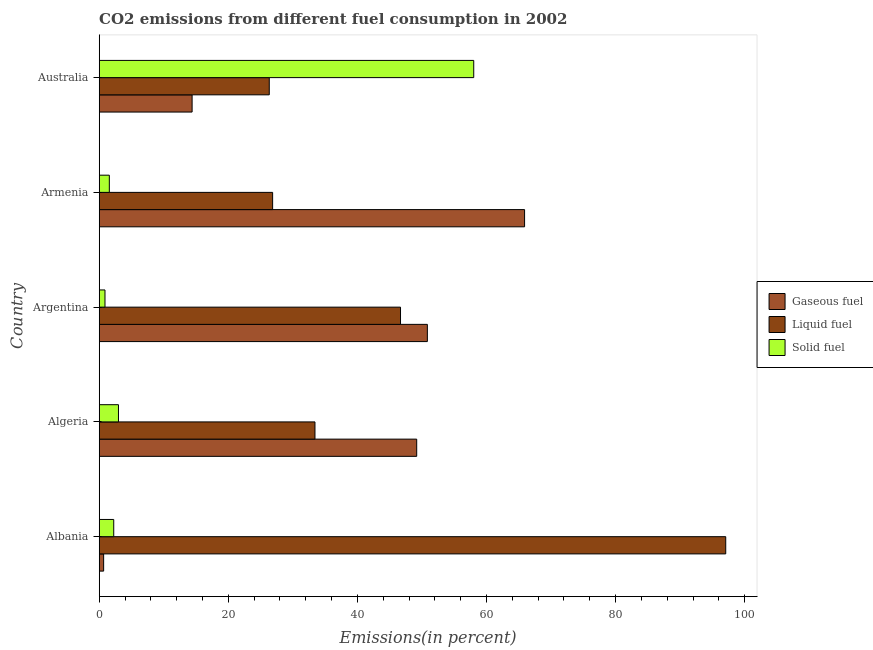How many different coloured bars are there?
Your answer should be compact. 3. Are the number of bars per tick equal to the number of legend labels?
Keep it short and to the point. Yes. How many bars are there on the 5th tick from the top?
Keep it short and to the point. 3. How many bars are there on the 3rd tick from the bottom?
Ensure brevity in your answer.  3. In how many cases, is the number of bars for a given country not equal to the number of legend labels?
Offer a very short reply. 0. What is the percentage of solid fuel emission in Argentina?
Give a very brief answer. 0.89. Across all countries, what is the maximum percentage of liquid fuel emission?
Your response must be concise. 97.07. Across all countries, what is the minimum percentage of gaseous fuel emission?
Make the answer very short. 0.68. In which country was the percentage of gaseous fuel emission maximum?
Offer a very short reply. Armenia. What is the total percentage of liquid fuel emission in the graph?
Your answer should be very brief. 230.39. What is the difference between the percentage of solid fuel emission in Armenia and that in Australia?
Offer a terse response. -56.46. What is the difference between the percentage of gaseous fuel emission in Argentina and the percentage of liquid fuel emission in Albania?
Your response must be concise. -46.23. What is the average percentage of gaseous fuel emission per country?
Offer a very short reply. 36.2. What is the difference between the percentage of gaseous fuel emission and percentage of liquid fuel emission in Albania?
Your response must be concise. -96.38. In how many countries, is the percentage of solid fuel emission greater than 8 %?
Your answer should be very brief. 1. What is the ratio of the percentage of solid fuel emission in Algeria to that in Armenia?
Your answer should be compact. 1.9. Is the percentage of liquid fuel emission in Albania less than that in Australia?
Your response must be concise. No. Is the difference between the percentage of liquid fuel emission in Albania and Australia greater than the difference between the percentage of solid fuel emission in Albania and Australia?
Your answer should be compact. Yes. What is the difference between the highest and the second highest percentage of gaseous fuel emission?
Provide a succinct answer. 15.06. What is the difference between the highest and the lowest percentage of liquid fuel emission?
Provide a succinct answer. 70.72. In how many countries, is the percentage of liquid fuel emission greater than the average percentage of liquid fuel emission taken over all countries?
Make the answer very short. 2. What does the 2nd bar from the top in Australia represents?
Make the answer very short. Liquid fuel. What does the 2nd bar from the bottom in Albania represents?
Your answer should be very brief. Liquid fuel. How many bars are there?
Your answer should be compact. 15. Are all the bars in the graph horizontal?
Offer a terse response. Yes. Are the values on the major ticks of X-axis written in scientific E-notation?
Offer a very short reply. No. Does the graph contain any zero values?
Keep it short and to the point. No. How many legend labels are there?
Offer a very short reply. 3. How are the legend labels stacked?
Your response must be concise. Vertical. What is the title of the graph?
Provide a short and direct response. CO2 emissions from different fuel consumption in 2002. What is the label or title of the X-axis?
Provide a short and direct response. Emissions(in percent). What is the Emissions(in percent) of Gaseous fuel in Albania?
Your answer should be compact. 0.68. What is the Emissions(in percent) in Liquid fuel in Albania?
Offer a very short reply. 97.07. What is the Emissions(in percent) of Solid fuel in Albania?
Your answer should be very brief. 2.25. What is the Emissions(in percent) in Gaseous fuel in Algeria?
Your answer should be very brief. 49.19. What is the Emissions(in percent) of Liquid fuel in Algeria?
Keep it short and to the point. 33.43. What is the Emissions(in percent) in Solid fuel in Algeria?
Make the answer very short. 2.98. What is the Emissions(in percent) of Gaseous fuel in Argentina?
Keep it short and to the point. 50.84. What is the Emissions(in percent) of Liquid fuel in Argentina?
Keep it short and to the point. 46.68. What is the Emissions(in percent) in Solid fuel in Argentina?
Your answer should be very brief. 0.89. What is the Emissions(in percent) of Gaseous fuel in Armenia?
Your answer should be compact. 65.9. What is the Emissions(in percent) in Liquid fuel in Armenia?
Provide a short and direct response. 26.87. What is the Emissions(in percent) of Solid fuel in Armenia?
Keep it short and to the point. 1.57. What is the Emissions(in percent) of Gaseous fuel in Australia?
Offer a very short reply. 14.39. What is the Emissions(in percent) in Liquid fuel in Australia?
Keep it short and to the point. 26.35. What is the Emissions(in percent) in Solid fuel in Australia?
Your answer should be compact. 58.03. Across all countries, what is the maximum Emissions(in percent) in Gaseous fuel?
Your answer should be compact. 65.9. Across all countries, what is the maximum Emissions(in percent) of Liquid fuel?
Provide a short and direct response. 97.07. Across all countries, what is the maximum Emissions(in percent) of Solid fuel?
Make the answer very short. 58.03. Across all countries, what is the minimum Emissions(in percent) in Gaseous fuel?
Provide a succinct answer. 0.68. Across all countries, what is the minimum Emissions(in percent) in Liquid fuel?
Provide a succinct answer. 26.35. Across all countries, what is the minimum Emissions(in percent) in Solid fuel?
Keep it short and to the point. 0.89. What is the total Emissions(in percent) in Gaseous fuel in the graph?
Offer a terse response. 181.01. What is the total Emissions(in percent) of Liquid fuel in the graph?
Provide a succinct answer. 230.39. What is the total Emissions(in percent) in Solid fuel in the graph?
Your response must be concise. 65.72. What is the difference between the Emissions(in percent) in Gaseous fuel in Albania and that in Algeria?
Provide a succinct answer. -48.5. What is the difference between the Emissions(in percent) in Liquid fuel in Albania and that in Algeria?
Give a very brief answer. 63.64. What is the difference between the Emissions(in percent) in Solid fuel in Albania and that in Algeria?
Your answer should be compact. -0.73. What is the difference between the Emissions(in percent) of Gaseous fuel in Albania and that in Argentina?
Offer a very short reply. -50.16. What is the difference between the Emissions(in percent) of Liquid fuel in Albania and that in Argentina?
Make the answer very short. 50.39. What is the difference between the Emissions(in percent) in Solid fuel in Albania and that in Argentina?
Offer a very short reply. 1.36. What is the difference between the Emissions(in percent) in Gaseous fuel in Albania and that in Armenia?
Give a very brief answer. -65.22. What is the difference between the Emissions(in percent) of Liquid fuel in Albania and that in Armenia?
Provide a succinct answer. 70.2. What is the difference between the Emissions(in percent) in Solid fuel in Albania and that in Armenia?
Offer a terse response. 0.68. What is the difference between the Emissions(in percent) of Gaseous fuel in Albania and that in Australia?
Keep it short and to the point. -13.71. What is the difference between the Emissions(in percent) of Liquid fuel in Albania and that in Australia?
Provide a succinct answer. 70.72. What is the difference between the Emissions(in percent) of Solid fuel in Albania and that in Australia?
Provide a succinct answer. -55.78. What is the difference between the Emissions(in percent) of Gaseous fuel in Algeria and that in Argentina?
Provide a succinct answer. -1.65. What is the difference between the Emissions(in percent) in Liquid fuel in Algeria and that in Argentina?
Give a very brief answer. -13.25. What is the difference between the Emissions(in percent) of Solid fuel in Algeria and that in Argentina?
Provide a short and direct response. 2.09. What is the difference between the Emissions(in percent) in Gaseous fuel in Algeria and that in Armenia?
Your response must be concise. -16.71. What is the difference between the Emissions(in percent) of Liquid fuel in Algeria and that in Armenia?
Make the answer very short. 6.56. What is the difference between the Emissions(in percent) in Solid fuel in Algeria and that in Armenia?
Ensure brevity in your answer.  1.42. What is the difference between the Emissions(in percent) in Gaseous fuel in Algeria and that in Australia?
Provide a short and direct response. 34.8. What is the difference between the Emissions(in percent) in Liquid fuel in Algeria and that in Australia?
Your answer should be compact. 7.08. What is the difference between the Emissions(in percent) in Solid fuel in Algeria and that in Australia?
Keep it short and to the point. -55.04. What is the difference between the Emissions(in percent) of Gaseous fuel in Argentina and that in Armenia?
Offer a terse response. -15.06. What is the difference between the Emissions(in percent) in Liquid fuel in Argentina and that in Armenia?
Offer a very short reply. 19.81. What is the difference between the Emissions(in percent) in Solid fuel in Argentina and that in Armenia?
Make the answer very short. -0.67. What is the difference between the Emissions(in percent) of Gaseous fuel in Argentina and that in Australia?
Offer a very short reply. 36.45. What is the difference between the Emissions(in percent) of Liquid fuel in Argentina and that in Australia?
Ensure brevity in your answer.  20.34. What is the difference between the Emissions(in percent) in Solid fuel in Argentina and that in Australia?
Your response must be concise. -57.13. What is the difference between the Emissions(in percent) in Gaseous fuel in Armenia and that in Australia?
Provide a succinct answer. 51.51. What is the difference between the Emissions(in percent) of Liquid fuel in Armenia and that in Australia?
Offer a very short reply. 0.52. What is the difference between the Emissions(in percent) of Solid fuel in Armenia and that in Australia?
Make the answer very short. -56.46. What is the difference between the Emissions(in percent) of Gaseous fuel in Albania and the Emissions(in percent) of Liquid fuel in Algeria?
Keep it short and to the point. -32.74. What is the difference between the Emissions(in percent) of Gaseous fuel in Albania and the Emissions(in percent) of Solid fuel in Algeria?
Provide a short and direct response. -2.3. What is the difference between the Emissions(in percent) in Liquid fuel in Albania and the Emissions(in percent) in Solid fuel in Algeria?
Give a very brief answer. 94.08. What is the difference between the Emissions(in percent) of Gaseous fuel in Albania and the Emissions(in percent) of Liquid fuel in Argentina?
Your answer should be very brief. -46. What is the difference between the Emissions(in percent) in Gaseous fuel in Albania and the Emissions(in percent) in Solid fuel in Argentina?
Provide a succinct answer. -0.21. What is the difference between the Emissions(in percent) in Liquid fuel in Albania and the Emissions(in percent) in Solid fuel in Argentina?
Your answer should be compact. 96.17. What is the difference between the Emissions(in percent) of Gaseous fuel in Albania and the Emissions(in percent) of Liquid fuel in Armenia?
Ensure brevity in your answer.  -26.18. What is the difference between the Emissions(in percent) of Gaseous fuel in Albania and the Emissions(in percent) of Solid fuel in Armenia?
Provide a short and direct response. -0.88. What is the difference between the Emissions(in percent) of Liquid fuel in Albania and the Emissions(in percent) of Solid fuel in Armenia?
Your answer should be very brief. 95.5. What is the difference between the Emissions(in percent) in Gaseous fuel in Albania and the Emissions(in percent) in Liquid fuel in Australia?
Offer a very short reply. -25.66. What is the difference between the Emissions(in percent) in Gaseous fuel in Albania and the Emissions(in percent) in Solid fuel in Australia?
Your answer should be compact. -57.34. What is the difference between the Emissions(in percent) of Liquid fuel in Albania and the Emissions(in percent) of Solid fuel in Australia?
Offer a very short reply. 39.04. What is the difference between the Emissions(in percent) in Gaseous fuel in Algeria and the Emissions(in percent) in Liquid fuel in Argentina?
Provide a succinct answer. 2.51. What is the difference between the Emissions(in percent) in Gaseous fuel in Algeria and the Emissions(in percent) in Solid fuel in Argentina?
Provide a succinct answer. 48.3. What is the difference between the Emissions(in percent) in Liquid fuel in Algeria and the Emissions(in percent) in Solid fuel in Argentina?
Your answer should be compact. 32.54. What is the difference between the Emissions(in percent) in Gaseous fuel in Algeria and the Emissions(in percent) in Liquid fuel in Armenia?
Keep it short and to the point. 22.32. What is the difference between the Emissions(in percent) of Gaseous fuel in Algeria and the Emissions(in percent) of Solid fuel in Armenia?
Provide a short and direct response. 47.62. What is the difference between the Emissions(in percent) in Liquid fuel in Algeria and the Emissions(in percent) in Solid fuel in Armenia?
Offer a very short reply. 31.86. What is the difference between the Emissions(in percent) in Gaseous fuel in Algeria and the Emissions(in percent) in Liquid fuel in Australia?
Ensure brevity in your answer.  22.84. What is the difference between the Emissions(in percent) in Gaseous fuel in Algeria and the Emissions(in percent) in Solid fuel in Australia?
Give a very brief answer. -8.84. What is the difference between the Emissions(in percent) of Liquid fuel in Algeria and the Emissions(in percent) of Solid fuel in Australia?
Your answer should be compact. -24.6. What is the difference between the Emissions(in percent) of Gaseous fuel in Argentina and the Emissions(in percent) of Liquid fuel in Armenia?
Offer a terse response. 23.97. What is the difference between the Emissions(in percent) of Gaseous fuel in Argentina and the Emissions(in percent) of Solid fuel in Armenia?
Provide a short and direct response. 49.27. What is the difference between the Emissions(in percent) in Liquid fuel in Argentina and the Emissions(in percent) in Solid fuel in Armenia?
Your response must be concise. 45.12. What is the difference between the Emissions(in percent) of Gaseous fuel in Argentina and the Emissions(in percent) of Liquid fuel in Australia?
Your answer should be very brief. 24.49. What is the difference between the Emissions(in percent) of Gaseous fuel in Argentina and the Emissions(in percent) of Solid fuel in Australia?
Provide a succinct answer. -7.19. What is the difference between the Emissions(in percent) of Liquid fuel in Argentina and the Emissions(in percent) of Solid fuel in Australia?
Ensure brevity in your answer.  -11.34. What is the difference between the Emissions(in percent) in Gaseous fuel in Armenia and the Emissions(in percent) in Liquid fuel in Australia?
Ensure brevity in your answer.  39.56. What is the difference between the Emissions(in percent) in Gaseous fuel in Armenia and the Emissions(in percent) in Solid fuel in Australia?
Your answer should be compact. 7.88. What is the difference between the Emissions(in percent) of Liquid fuel in Armenia and the Emissions(in percent) of Solid fuel in Australia?
Offer a terse response. -31.16. What is the average Emissions(in percent) of Gaseous fuel per country?
Provide a short and direct response. 36.2. What is the average Emissions(in percent) in Liquid fuel per country?
Your answer should be compact. 46.08. What is the average Emissions(in percent) of Solid fuel per country?
Your response must be concise. 13.14. What is the difference between the Emissions(in percent) in Gaseous fuel and Emissions(in percent) in Liquid fuel in Albania?
Make the answer very short. -96.38. What is the difference between the Emissions(in percent) in Gaseous fuel and Emissions(in percent) in Solid fuel in Albania?
Offer a terse response. -1.56. What is the difference between the Emissions(in percent) of Liquid fuel and Emissions(in percent) of Solid fuel in Albania?
Offer a very short reply. 94.82. What is the difference between the Emissions(in percent) in Gaseous fuel and Emissions(in percent) in Liquid fuel in Algeria?
Provide a succinct answer. 15.76. What is the difference between the Emissions(in percent) of Gaseous fuel and Emissions(in percent) of Solid fuel in Algeria?
Your answer should be compact. 46.21. What is the difference between the Emissions(in percent) of Liquid fuel and Emissions(in percent) of Solid fuel in Algeria?
Your answer should be very brief. 30.44. What is the difference between the Emissions(in percent) in Gaseous fuel and Emissions(in percent) in Liquid fuel in Argentina?
Your answer should be compact. 4.16. What is the difference between the Emissions(in percent) of Gaseous fuel and Emissions(in percent) of Solid fuel in Argentina?
Keep it short and to the point. 49.95. What is the difference between the Emissions(in percent) in Liquid fuel and Emissions(in percent) in Solid fuel in Argentina?
Ensure brevity in your answer.  45.79. What is the difference between the Emissions(in percent) of Gaseous fuel and Emissions(in percent) of Liquid fuel in Armenia?
Ensure brevity in your answer.  39.04. What is the difference between the Emissions(in percent) of Gaseous fuel and Emissions(in percent) of Solid fuel in Armenia?
Offer a terse response. 64.34. What is the difference between the Emissions(in percent) in Liquid fuel and Emissions(in percent) in Solid fuel in Armenia?
Give a very brief answer. 25.3. What is the difference between the Emissions(in percent) in Gaseous fuel and Emissions(in percent) in Liquid fuel in Australia?
Provide a succinct answer. -11.95. What is the difference between the Emissions(in percent) of Gaseous fuel and Emissions(in percent) of Solid fuel in Australia?
Offer a very short reply. -43.63. What is the difference between the Emissions(in percent) in Liquid fuel and Emissions(in percent) in Solid fuel in Australia?
Provide a short and direct response. -31.68. What is the ratio of the Emissions(in percent) in Gaseous fuel in Albania to that in Algeria?
Make the answer very short. 0.01. What is the ratio of the Emissions(in percent) in Liquid fuel in Albania to that in Algeria?
Offer a terse response. 2.9. What is the ratio of the Emissions(in percent) in Solid fuel in Albania to that in Algeria?
Give a very brief answer. 0.75. What is the ratio of the Emissions(in percent) in Gaseous fuel in Albania to that in Argentina?
Your response must be concise. 0.01. What is the ratio of the Emissions(in percent) in Liquid fuel in Albania to that in Argentina?
Give a very brief answer. 2.08. What is the ratio of the Emissions(in percent) in Solid fuel in Albania to that in Argentina?
Your response must be concise. 2.52. What is the ratio of the Emissions(in percent) in Gaseous fuel in Albania to that in Armenia?
Offer a very short reply. 0.01. What is the ratio of the Emissions(in percent) in Liquid fuel in Albania to that in Armenia?
Make the answer very short. 3.61. What is the ratio of the Emissions(in percent) of Solid fuel in Albania to that in Armenia?
Make the answer very short. 1.44. What is the ratio of the Emissions(in percent) in Gaseous fuel in Albania to that in Australia?
Provide a short and direct response. 0.05. What is the ratio of the Emissions(in percent) in Liquid fuel in Albania to that in Australia?
Make the answer very short. 3.68. What is the ratio of the Emissions(in percent) in Solid fuel in Albania to that in Australia?
Offer a terse response. 0.04. What is the ratio of the Emissions(in percent) in Gaseous fuel in Algeria to that in Argentina?
Provide a short and direct response. 0.97. What is the ratio of the Emissions(in percent) in Liquid fuel in Algeria to that in Argentina?
Offer a terse response. 0.72. What is the ratio of the Emissions(in percent) in Solid fuel in Algeria to that in Argentina?
Your response must be concise. 3.34. What is the ratio of the Emissions(in percent) in Gaseous fuel in Algeria to that in Armenia?
Your answer should be compact. 0.75. What is the ratio of the Emissions(in percent) in Liquid fuel in Algeria to that in Armenia?
Keep it short and to the point. 1.24. What is the ratio of the Emissions(in percent) in Solid fuel in Algeria to that in Armenia?
Provide a short and direct response. 1.9. What is the ratio of the Emissions(in percent) in Gaseous fuel in Algeria to that in Australia?
Offer a terse response. 3.42. What is the ratio of the Emissions(in percent) in Liquid fuel in Algeria to that in Australia?
Ensure brevity in your answer.  1.27. What is the ratio of the Emissions(in percent) of Solid fuel in Algeria to that in Australia?
Ensure brevity in your answer.  0.05. What is the ratio of the Emissions(in percent) in Gaseous fuel in Argentina to that in Armenia?
Give a very brief answer. 0.77. What is the ratio of the Emissions(in percent) in Liquid fuel in Argentina to that in Armenia?
Offer a very short reply. 1.74. What is the ratio of the Emissions(in percent) in Solid fuel in Argentina to that in Armenia?
Keep it short and to the point. 0.57. What is the ratio of the Emissions(in percent) in Gaseous fuel in Argentina to that in Australia?
Provide a short and direct response. 3.53. What is the ratio of the Emissions(in percent) in Liquid fuel in Argentina to that in Australia?
Provide a short and direct response. 1.77. What is the ratio of the Emissions(in percent) of Solid fuel in Argentina to that in Australia?
Ensure brevity in your answer.  0.02. What is the ratio of the Emissions(in percent) of Gaseous fuel in Armenia to that in Australia?
Your answer should be compact. 4.58. What is the ratio of the Emissions(in percent) in Liquid fuel in Armenia to that in Australia?
Your answer should be very brief. 1.02. What is the ratio of the Emissions(in percent) in Solid fuel in Armenia to that in Australia?
Give a very brief answer. 0.03. What is the difference between the highest and the second highest Emissions(in percent) of Gaseous fuel?
Offer a very short reply. 15.06. What is the difference between the highest and the second highest Emissions(in percent) in Liquid fuel?
Keep it short and to the point. 50.39. What is the difference between the highest and the second highest Emissions(in percent) of Solid fuel?
Provide a short and direct response. 55.04. What is the difference between the highest and the lowest Emissions(in percent) in Gaseous fuel?
Keep it short and to the point. 65.22. What is the difference between the highest and the lowest Emissions(in percent) in Liquid fuel?
Your response must be concise. 70.72. What is the difference between the highest and the lowest Emissions(in percent) in Solid fuel?
Offer a very short reply. 57.13. 